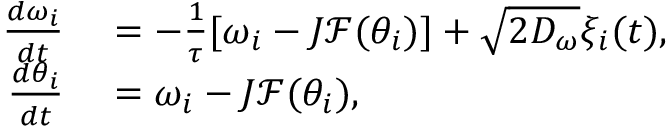<formula> <loc_0><loc_0><loc_500><loc_500>\begin{array} { r l } { \frac { d \omega _ { i } } { d t } } & = - \frac { 1 } { \tau } [ \omega _ { i } - J \mathcal { F } ( \theta _ { i } ) ] + \sqrt { 2 D _ { \omega } } \xi _ { i } ( t ) , } \\ { \frac { d \theta _ { i } } { d t } } & = \omega _ { i } - J \mathcal { F } ( \theta _ { i } ) , } \end{array}</formula> 